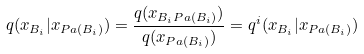Convert formula to latex. <formula><loc_0><loc_0><loc_500><loc_500>q ( x _ { B _ { i } } | x _ { P a ( B _ { i } ) } ) = \frac { q ( x _ { B _ { i } P a ( B _ { i } ) } ) } { q ( x _ { P a ( B _ { i } ) } ) } = q ^ { i } ( x _ { B _ { i } } | x _ { P a ( B _ { i } ) } )</formula> 